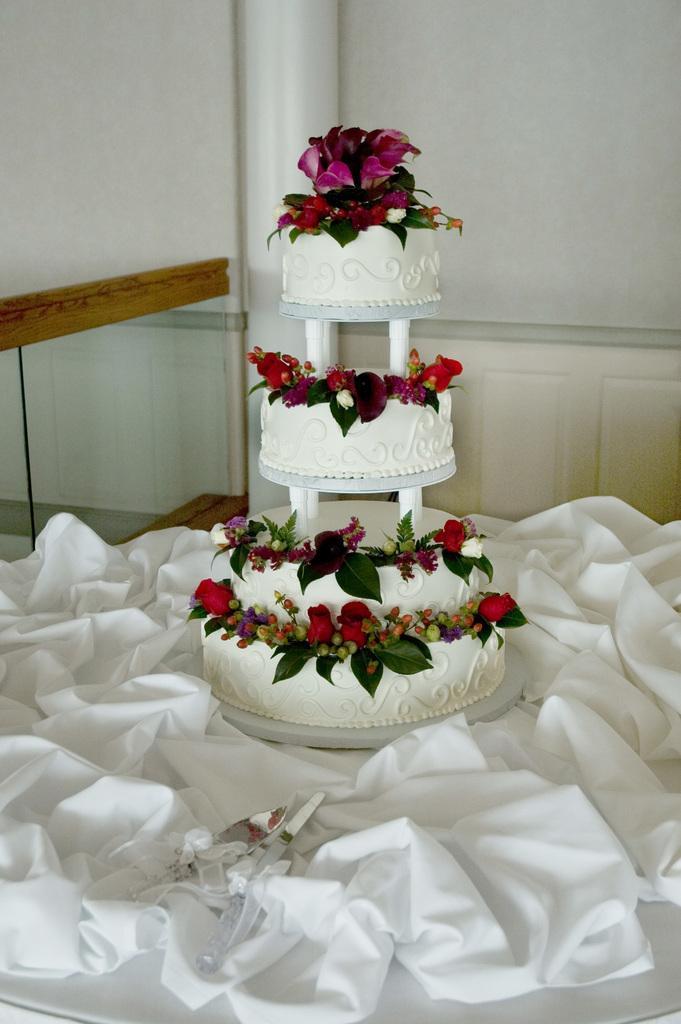Could you give a brief overview of what you see in this image? Here we can see a cake, cloth, and a knife on the table. In the background we can see wall. 